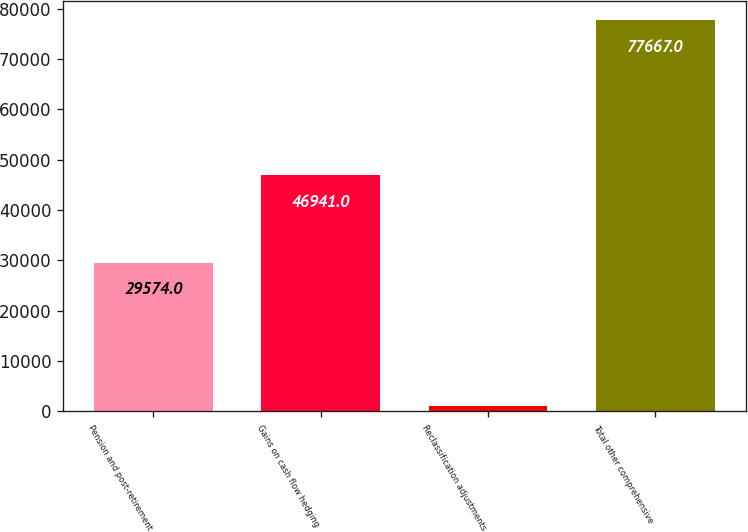<chart> <loc_0><loc_0><loc_500><loc_500><bar_chart><fcel>Pension and post-retirement<fcel>Gains on cash flow hedging<fcel>Reclassification adjustments<fcel>Total other comprehensive<nl><fcel>29574<fcel>46941<fcel>1152<fcel>77667<nl></chart> 